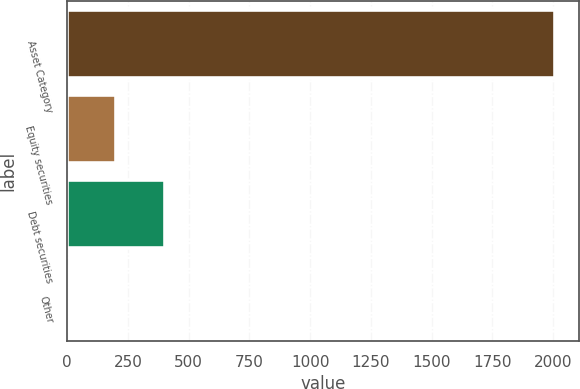<chart> <loc_0><loc_0><loc_500><loc_500><bar_chart><fcel>Asset Category<fcel>Equity securities<fcel>Debt securities<fcel>Other<nl><fcel>2007<fcel>201.6<fcel>402.2<fcel>1<nl></chart> 